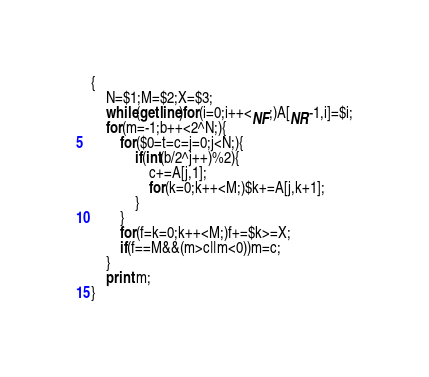Convert code to text. <code><loc_0><loc_0><loc_500><loc_500><_Awk_>{
    N=$1;M=$2;X=$3;
    while(getline)for(i=0;i++<NF;)A[NR-1,i]=$i;
    for(m=-1;b++<2^N;){
        for($0=t=c=j=0;j<N;){
            if(int(b/2^j++)%2){
                c+=A[j,1];
                for(k=0;k++<M;)$k+=A[j,k+1];
            }
        }
        for(f=k=0;k++<M;)f+=$k>=X;
        if(f==M&&(m>c||m<0))m=c;
    }
    print m;
}</code> 